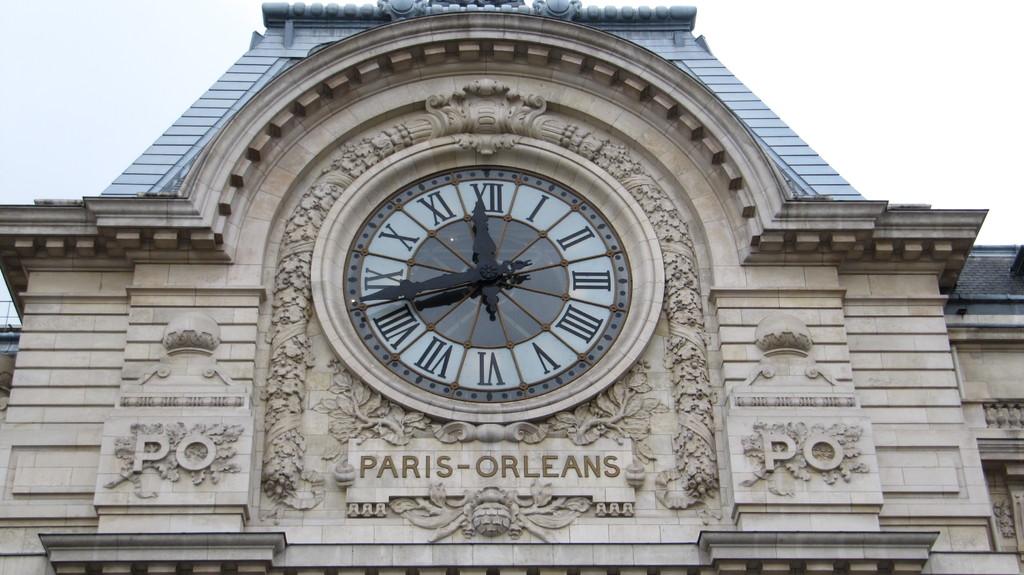Whats the time on theclock?
Offer a very short reply. 11:43. 